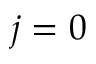<formula> <loc_0><loc_0><loc_500><loc_500>j = 0</formula> 